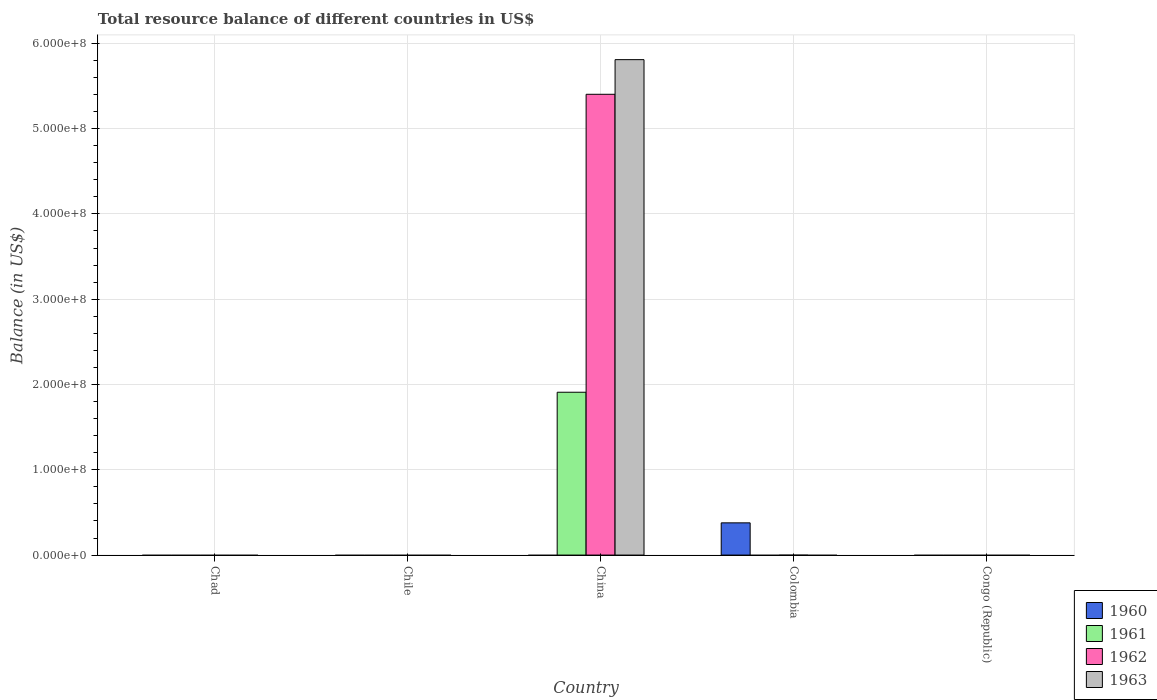Are the number of bars per tick equal to the number of legend labels?
Provide a short and direct response. No. Are the number of bars on each tick of the X-axis equal?
Your response must be concise. No. How many bars are there on the 2nd tick from the right?
Your response must be concise. 1. What is the label of the 1st group of bars from the left?
Make the answer very short. Chad. In how many cases, is the number of bars for a given country not equal to the number of legend labels?
Provide a short and direct response. 5. Across all countries, what is the maximum total resource balance in 1961?
Give a very brief answer. 1.91e+08. Across all countries, what is the minimum total resource balance in 1961?
Keep it short and to the point. 0. What is the total total resource balance in 1961 in the graph?
Provide a short and direct response. 1.91e+08. What is the difference between the total resource balance in 1962 in Congo (Republic) and the total resource balance in 1960 in China?
Ensure brevity in your answer.  0. What is the average total resource balance in 1962 per country?
Your answer should be compact. 1.08e+08. What is the difference between the total resource balance of/in 1961 and total resource balance of/in 1963 in China?
Give a very brief answer. -3.90e+08. In how many countries, is the total resource balance in 1963 greater than 20000000 US$?
Provide a succinct answer. 1. What is the difference between the highest and the lowest total resource balance in 1962?
Provide a succinct answer. 5.40e+08. Is it the case that in every country, the sum of the total resource balance in 1962 and total resource balance in 1961 is greater than the sum of total resource balance in 1963 and total resource balance in 1960?
Provide a short and direct response. No. Is it the case that in every country, the sum of the total resource balance in 1962 and total resource balance in 1960 is greater than the total resource balance in 1961?
Ensure brevity in your answer.  No. Are all the bars in the graph horizontal?
Give a very brief answer. No. How many countries are there in the graph?
Your answer should be compact. 5. What is the difference between two consecutive major ticks on the Y-axis?
Make the answer very short. 1.00e+08. Are the values on the major ticks of Y-axis written in scientific E-notation?
Offer a terse response. Yes. Does the graph contain any zero values?
Offer a terse response. Yes. How many legend labels are there?
Provide a succinct answer. 4. What is the title of the graph?
Give a very brief answer. Total resource balance of different countries in US$. Does "1978" appear as one of the legend labels in the graph?
Keep it short and to the point. No. What is the label or title of the Y-axis?
Provide a short and direct response. Balance (in US$). What is the Balance (in US$) in 1962 in Chad?
Offer a terse response. 0. What is the Balance (in US$) in 1963 in Chad?
Keep it short and to the point. 0. What is the Balance (in US$) of 1960 in Chile?
Make the answer very short. 0. What is the Balance (in US$) in 1962 in Chile?
Make the answer very short. 0. What is the Balance (in US$) of 1963 in Chile?
Make the answer very short. 0. What is the Balance (in US$) of 1960 in China?
Make the answer very short. 0. What is the Balance (in US$) in 1961 in China?
Your answer should be compact. 1.91e+08. What is the Balance (in US$) of 1962 in China?
Your answer should be compact. 5.40e+08. What is the Balance (in US$) in 1963 in China?
Ensure brevity in your answer.  5.81e+08. What is the Balance (in US$) in 1960 in Colombia?
Ensure brevity in your answer.  3.78e+07. What is the Balance (in US$) of 1962 in Colombia?
Give a very brief answer. 0. What is the Balance (in US$) of 1963 in Colombia?
Make the answer very short. 0. What is the Balance (in US$) of 1961 in Congo (Republic)?
Give a very brief answer. 0. What is the Balance (in US$) in 1962 in Congo (Republic)?
Your answer should be compact. 0. Across all countries, what is the maximum Balance (in US$) of 1960?
Offer a terse response. 3.78e+07. Across all countries, what is the maximum Balance (in US$) in 1961?
Make the answer very short. 1.91e+08. Across all countries, what is the maximum Balance (in US$) in 1962?
Keep it short and to the point. 5.40e+08. Across all countries, what is the maximum Balance (in US$) in 1963?
Your answer should be compact. 5.81e+08. Across all countries, what is the minimum Balance (in US$) of 1960?
Make the answer very short. 0. Across all countries, what is the minimum Balance (in US$) of 1961?
Give a very brief answer. 0. What is the total Balance (in US$) in 1960 in the graph?
Your answer should be very brief. 3.78e+07. What is the total Balance (in US$) in 1961 in the graph?
Make the answer very short. 1.91e+08. What is the total Balance (in US$) in 1962 in the graph?
Make the answer very short. 5.40e+08. What is the total Balance (in US$) of 1963 in the graph?
Provide a succinct answer. 5.81e+08. What is the average Balance (in US$) of 1960 per country?
Ensure brevity in your answer.  7.56e+06. What is the average Balance (in US$) of 1961 per country?
Make the answer very short. 3.82e+07. What is the average Balance (in US$) in 1962 per country?
Your response must be concise. 1.08e+08. What is the average Balance (in US$) of 1963 per country?
Provide a short and direct response. 1.16e+08. What is the difference between the Balance (in US$) in 1961 and Balance (in US$) in 1962 in China?
Keep it short and to the point. -3.49e+08. What is the difference between the Balance (in US$) in 1961 and Balance (in US$) in 1963 in China?
Ensure brevity in your answer.  -3.90e+08. What is the difference between the Balance (in US$) of 1962 and Balance (in US$) of 1963 in China?
Keep it short and to the point. -4.06e+07. What is the difference between the highest and the lowest Balance (in US$) in 1960?
Provide a succinct answer. 3.78e+07. What is the difference between the highest and the lowest Balance (in US$) of 1961?
Your response must be concise. 1.91e+08. What is the difference between the highest and the lowest Balance (in US$) in 1962?
Ensure brevity in your answer.  5.40e+08. What is the difference between the highest and the lowest Balance (in US$) of 1963?
Ensure brevity in your answer.  5.81e+08. 